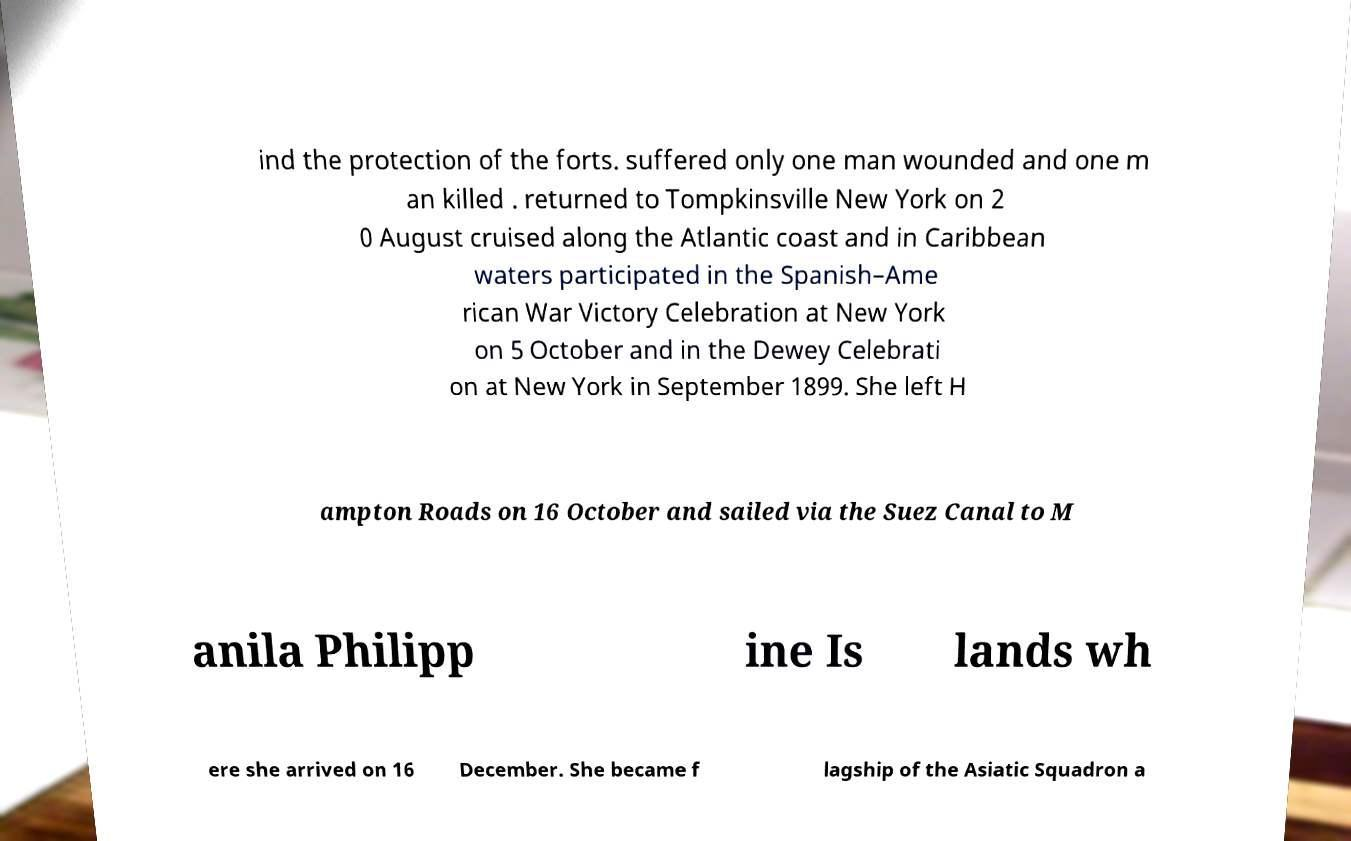Can you accurately transcribe the text from the provided image for me? ind the protection of the forts. suffered only one man wounded and one m an killed . returned to Tompkinsville New York on 2 0 August cruised along the Atlantic coast and in Caribbean waters participated in the Spanish–Ame rican War Victory Celebration at New York on 5 October and in the Dewey Celebrati on at New York in September 1899. She left H ampton Roads on 16 October and sailed via the Suez Canal to M anila Philipp ine Is lands wh ere she arrived on 16 December. She became f lagship of the Asiatic Squadron a 